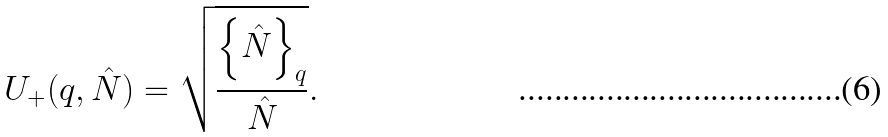Convert formula to latex. <formula><loc_0><loc_0><loc_500><loc_500>U _ { + } ( q , \hat { N } ) = \sqrt { \frac { \left \{ \hat { N } \right \} _ { q } } { \hat { N } } } .</formula> 